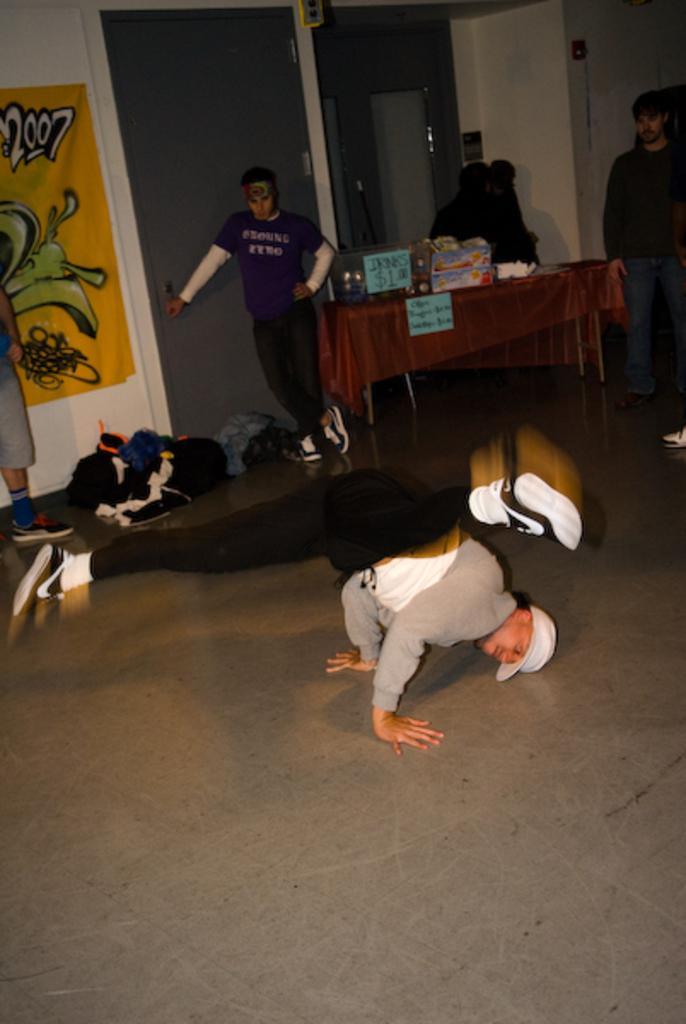Describe this image in one or two sentences. In this image there is one person who is dancing, and in the background there are some persons who are standing and there is one table. On the table there are some objects, beside the table there are some clothes. And in the background there is a poster and a glass window, at the bottom there is a floor. 